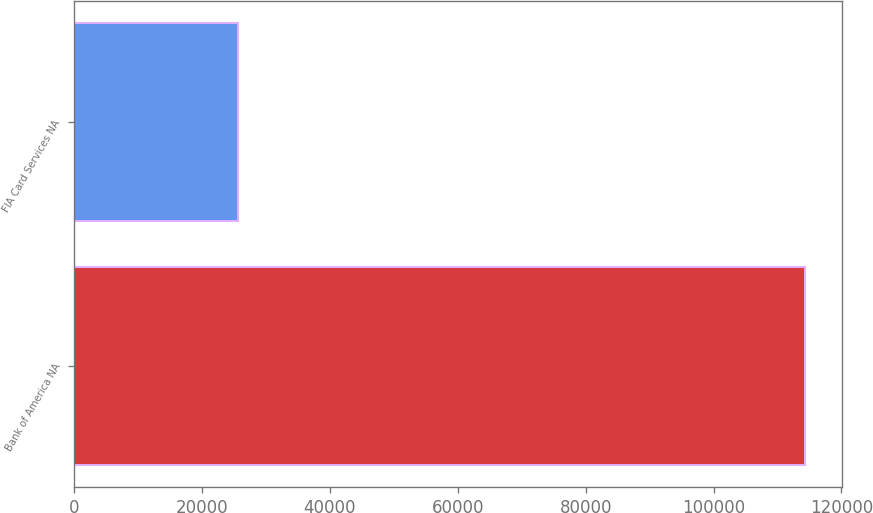<chart> <loc_0><loc_0><loc_500><loc_500><bar_chart><fcel>Bank of America NA<fcel>FIA Card Services NA<nl><fcel>114345<fcel>25589<nl></chart> 